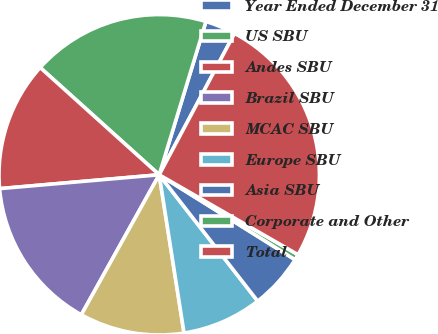Convert chart to OTSL. <chart><loc_0><loc_0><loc_500><loc_500><pie_chart><fcel>Year Ended December 31<fcel>US SBU<fcel>Andes SBU<fcel>Brazil SBU<fcel>MCAC SBU<fcel>Europe SBU<fcel>Asia SBU<fcel>Corporate and Other<fcel>Total<nl><fcel>3.08%<fcel>18.04%<fcel>13.05%<fcel>15.54%<fcel>10.56%<fcel>8.06%<fcel>5.57%<fcel>0.58%<fcel>25.52%<nl></chart> 